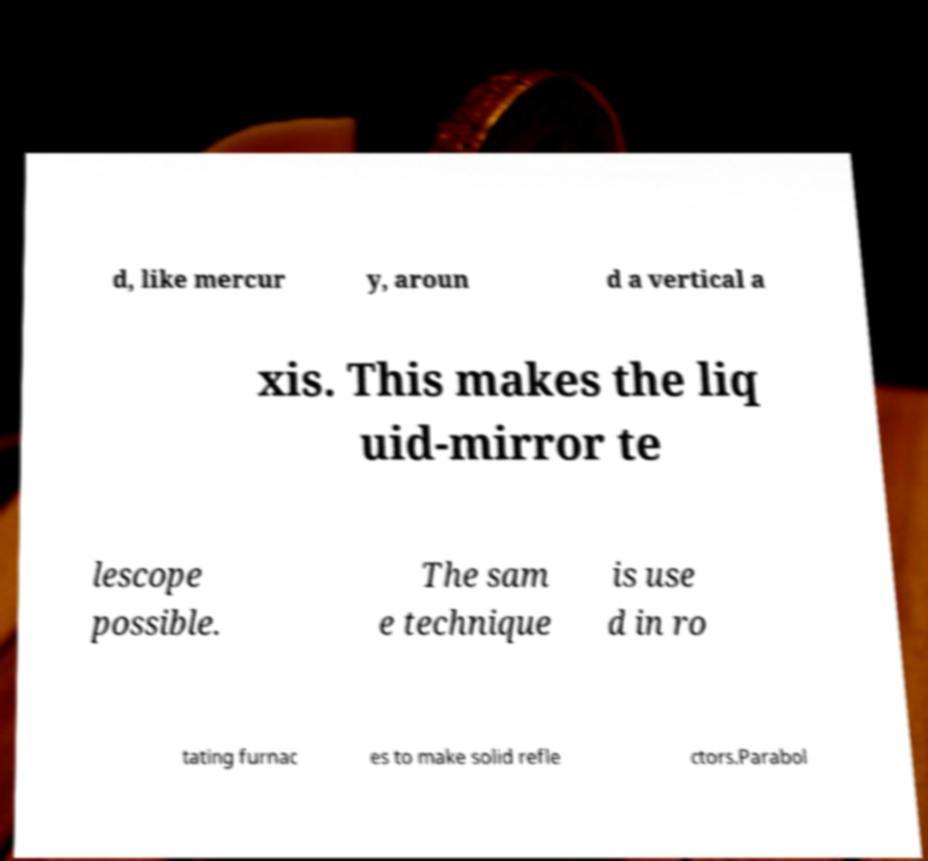Can you read and provide the text displayed in the image?This photo seems to have some interesting text. Can you extract and type it out for me? d, like mercur y, aroun d a vertical a xis. This makes the liq uid-mirror te lescope possible. The sam e technique is use d in ro tating furnac es to make solid refle ctors.Parabol 